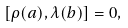<formula> <loc_0><loc_0><loc_500><loc_500>[ \rho ( a ) , \lambda ( b ) ] = 0 ,</formula> 